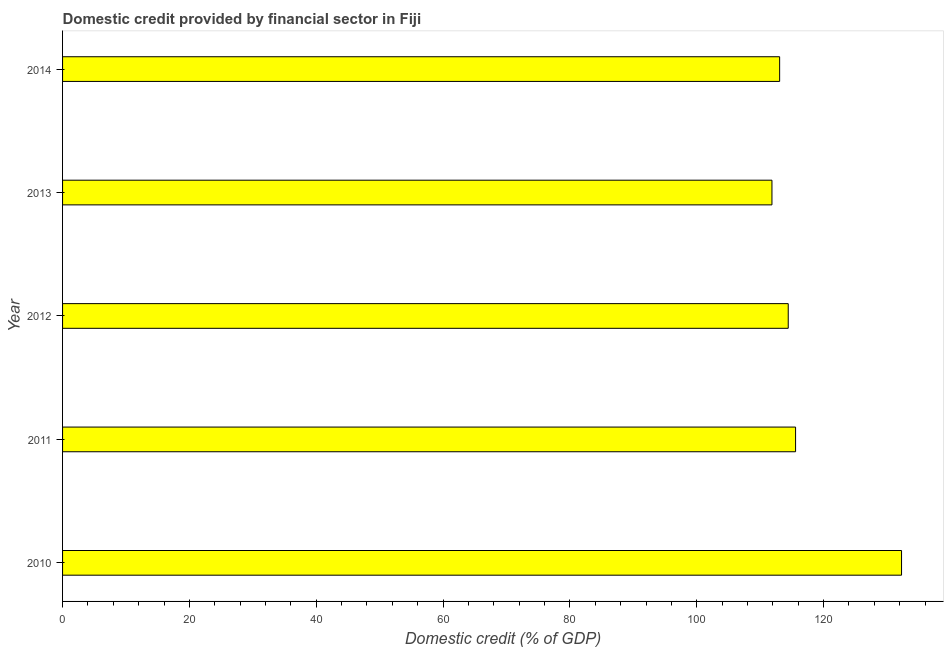What is the title of the graph?
Offer a terse response. Domestic credit provided by financial sector in Fiji. What is the label or title of the X-axis?
Offer a very short reply. Domestic credit (% of GDP). What is the label or title of the Y-axis?
Make the answer very short. Year. What is the domestic credit provided by financial sector in 2014?
Offer a terse response. 113.07. Across all years, what is the maximum domestic credit provided by financial sector?
Your answer should be compact. 132.3. Across all years, what is the minimum domestic credit provided by financial sector?
Offer a terse response. 111.86. In which year was the domestic credit provided by financial sector maximum?
Ensure brevity in your answer.  2010. In which year was the domestic credit provided by financial sector minimum?
Offer a terse response. 2013. What is the sum of the domestic credit provided by financial sector?
Give a very brief answer. 587.24. What is the difference between the domestic credit provided by financial sector in 2013 and 2014?
Your answer should be very brief. -1.21. What is the average domestic credit provided by financial sector per year?
Ensure brevity in your answer.  117.45. What is the median domestic credit provided by financial sector?
Your response must be concise. 114.43. In how many years, is the domestic credit provided by financial sector greater than 40 %?
Make the answer very short. 5. Do a majority of the years between 2014 and 2011 (inclusive) have domestic credit provided by financial sector greater than 44 %?
Ensure brevity in your answer.  Yes. What is the ratio of the domestic credit provided by financial sector in 2012 to that in 2013?
Your response must be concise. 1.02. Is the difference between the domestic credit provided by financial sector in 2011 and 2014 greater than the difference between any two years?
Your answer should be compact. No. What is the difference between the highest and the second highest domestic credit provided by financial sector?
Offer a very short reply. 16.71. What is the difference between the highest and the lowest domestic credit provided by financial sector?
Give a very brief answer. 20.43. How many bars are there?
Offer a very short reply. 5. Are all the bars in the graph horizontal?
Your answer should be very brief. Yes. How many years are there in the graph?
Keep it short and to the point. 5. Are the values on the major ticks of X-axis written in scientific E-notation?
Your answer should be very brief. No. What is the Domestic credit (% of GDP) of 2010?
Your answer should be very brief. 132.3. What is the Domestic credit (% of GDP) in 2011?
Give a very brief answer. 115.59. What is the Domestic credit (% of GDP) of 2012?
Your answer should be compact. 114.43. What is the Domestic credit (% of GDP) of 2013?
Provide a short and direct response. 111.86. What is the Domestic credit (% of GDP) in 2014?
Provide a short and direct response. 113.07. What is the difference between the Domestic credit (% of GDP) in 2010 and 2011?
Your answer should be compact. 16.71. What is the difference between the Domestic credit (% of GDP) in 2010 and 2012?
Offer a very short reply. 17.87. What is the difference between the Domestic credit (% of GDP) in 2010 and 2013?
Provide a short and direct response. 20.43. What is the difference between the Domestic credit (% of GDP) in 2010 and 2014?
Offer a terse response. 19.22. What is the difference between the Domestic credit (% of GDP) in 2011 and 2012?
Ensure brevity in your answer.  1.16. What is the difference between the Domestic credit (% of GDP) in 2011 and 2013?
Your answer should be very brief. 3.73. What is the difference between the Domestic credit (% of GDP) in 2011 and 2014?
Keep it short and to the point. 2.51. What is the difference between the Domestic credit (% of GDP) in 2012 and 2013?
Give a very brief answer. 2.57. What is the difference between the Domestic credit (% of GDP) in 2012 and 2014?
Offer a terse response. 1.36. What is the difference between the Domestic credit (% of GDP) in 2013 and 2014?
Offer a terse response. -1.21. What is the ratio of the Domestic credit (% of GDP) in 2010 to that in 2011?
Your answer should be very brief. 1.15. What is the ratio of the Domestic credit (% of GDP) in 2010 to that in 2012?
Your answer should be compact. 1.16. What is the ratio of the Domestic credit (% of GDP) in 2010 to that in 2013?
Offer a terse response. 1.18. What is the ratio of the Domestic credit (% of GDP) in 2010 to that in 2014?
Your response must be concise. 1.17. What is the ratio of the Domestic credit (% of GDP) in 2011 to that in 2012?
Your response must be concise. 1.01. What is the ratio of the Domestic credit (% of GDP) in 2011 to that in 2013?
Keep it short and to the point. 1.03. What is the ratio of the Domestic credit (% of GDP) in 2012 to that in 2013?
Make the answer very short. 1.02. What is the ratio of the Domestic credit (% of GDP) in 2012 to that in 2014?
Provide a succinct answer. 1.01. What is the ratio of the Domestic credit (% of GDP) in 2013 to that in 2014?
Your response must be concise. 0.99. 